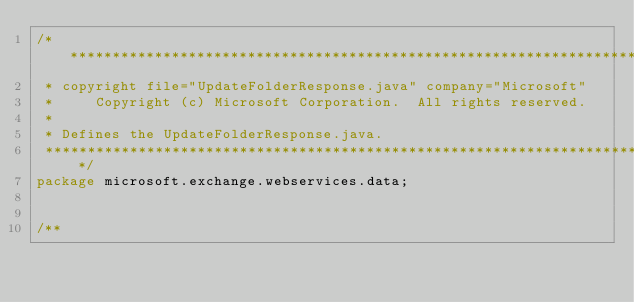<code> <loc_0><loc_0><loc_500><loc_500><_Java_>/**************************************************************************
 * copyright file="UpdateFolderResponse.java" company="Microsoft"
 *     Copyright (c) Microsoft Corporation.  All rights reserved.
 * 
 * Defines the UpdateFolderResponse.java.
 **************************************************************************/
package microsoft.exchange.webservices.data;


/**</code> 